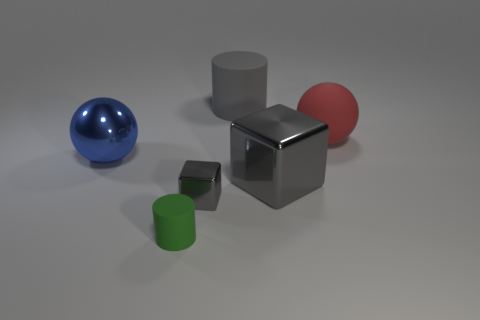Add 4 big gray things. How many objects exist? 10 Subtract all blocks. How many objects are left? 4 Add 5 tiny gray blocks. How many tiny gray blocks are left? 6 Add 6 tiny cubes. How many tiny cubes exist? 7 Subtract 1 green cylinders. How many objects are left? 5 Subtract all tiny green rubber objects. Subtract all large gray matte cylinders. How many objects are left? 4 